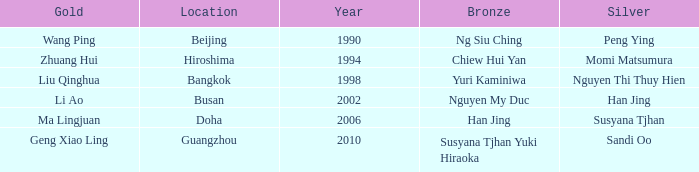What Silver has the Location of Guangzhou? Sandi Oo. Could you parse the entire table as a dict? {'header': ['Gold', 'Location', 'Year', 'Bronze', 'Silver'], 'rows': [['Wang Ping', 'Beijing', '1990', 'Ng Siu Ching', 'Peng Ying'], ['Zhuang Hui', 'Hiroshima', '1994', 'Chiew Hui Yan', 'Momi Matsumura'], ['Liu Qinghua', 'Bangkok', '1998', 'Yuri Kaminiwa', 'Nguyen Thi Thuy Hien'], ['Li Ao', 'Busan', '2002', 'Nguyen My Duc', 'Han Jing'], ['Ma Lingjuan', 'Doha', '2006', 'Han Jing', 'Susyana Tjhan'], ['Geng Xiao Ling', 'Guangzhou', '2010', 'Susyana Tjhan Yuki Hiraoka', 'Sandi Oo']]} 